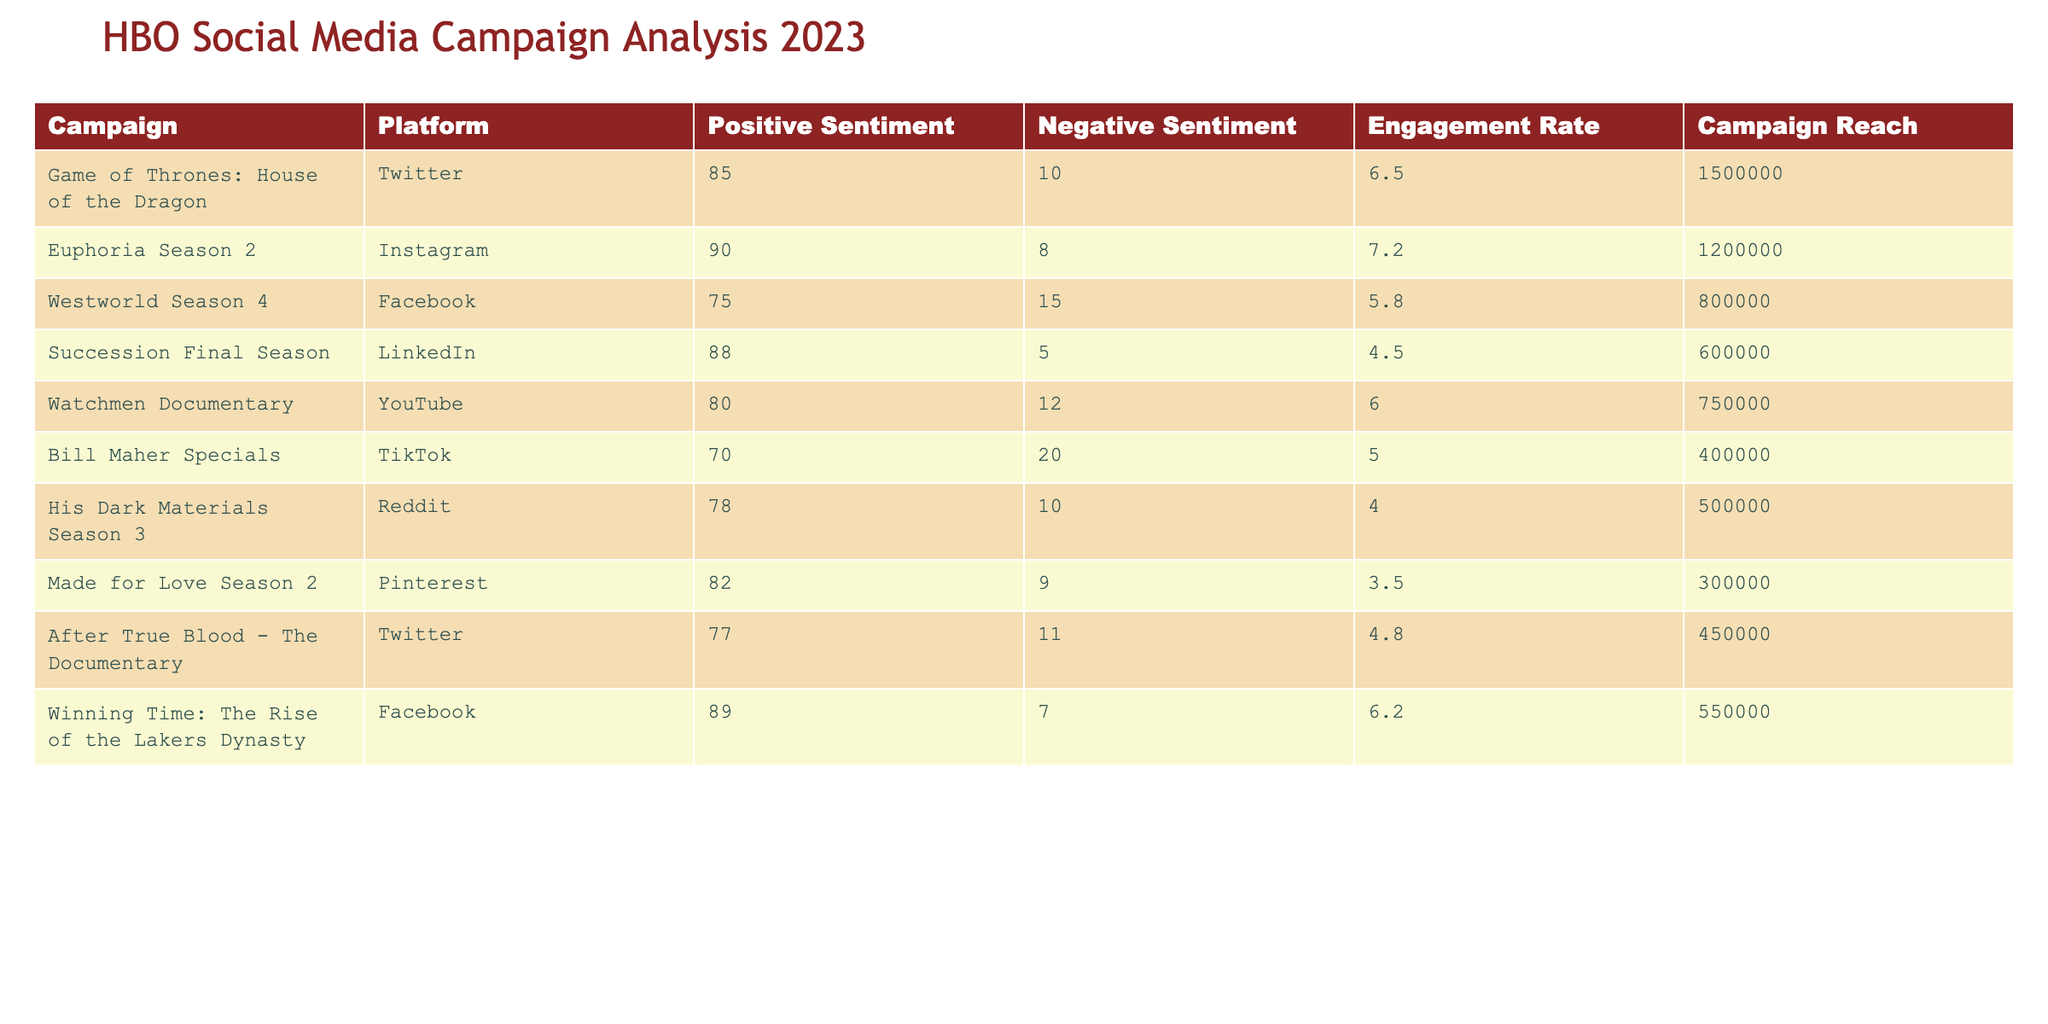What campaign had the highest positive sentiment? Looking at the "Positive Sentiment" column, "Euphoria Season 2" has the highest value of 90.
Answer: Euphoria Season 2 Which campaign had the lowest engagement rate? Checking the "Engagement Rate" column, "Made for Love Season 2" has the lowest value of 3.5.
Answer: Made for Love Season 2 What is the difference in negative sentiment between the "Westworld Season 4" and "Succession Final Season"? "Westworld Season 4" has a negative sentiment of 15, and "Succession Final Season" has 5. The difference is 15 - 5 = 10.
Answer: 10 Which platforms showed a positive sentiment above 80? By analyzing the "Positive Sentiment" column, the campaigns on Twitter, Instagram, LinkedIn, YouTube, and Pinterest all have values above 80.
Answer: Twitter, Instagram, LinkedIn, YouTube, Pinterest Is the campaign "Bill Maher Specials" more positively received than "Winning Time: The Rise of the Lakers Dynasty"? Comparing the positive sentiments, "Bill Maher Specials" has 70 and "Winning Time" has 89. Since 70 is less than 89, the statement is false.
Answer: No What is the average engagement rate of all campaigns? Adding the engagement rates: 6.5 + 7.2 + 5.8 + 4.5 + 6.0 + 5.0 + 4.0 + 3.5 + 4.8 + 6.2 = 53.5. There are 10 campaigns, so the average engagement rate is 53.5 / 10 = 5.35.
Answer: 5.35 Which campaign had the highest reach? Checking the "Campaign Reach" column, "Game of Thrones: House of the Dragon" has the highest reach with 1,500,000.
Answer: Game of Thrones: House of the Dragon How many campaigns had a negative sentiment of 10 or lower? The campaigns with a negative sentiment of 10 or lower are "Euphoria Season 2" (8) and "Succession Final Season" (5), making a total of 2 campaigns.
Answer: 2 Which platform had the lowest reach for HBO's campaigns? Reviewing the "Campaign Reach" column, "Made for Love Season 2" has the lowest reach at 300,000.
Answer: Made for Love Season 2 